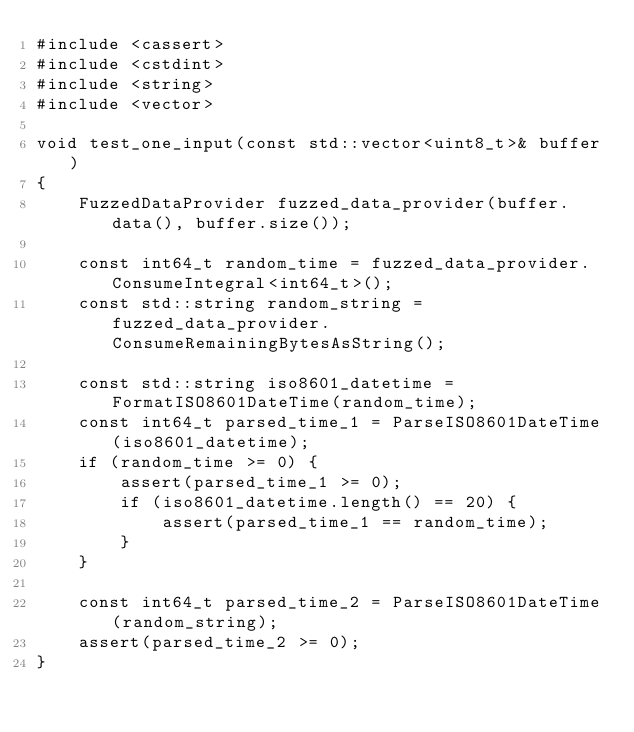Convert code to text. <code><loc_0><loc_0><loc_500><loc_500><_C++_>#include <cassert>
#include <cstdint>
#include <string>
#include <vector>

void test_one_input(const std::vector<uint8_t>& buffer)
{
    FuzzedDataProvider fuzzed_data_provider(buffer.data(), buffer.size());

    const int64_t random_time = fuzzed_data_provider.ConsumeIntegral<int64_t>();
    const std::string random_string = fuzzed_data_provider.ConsumeRemainingBytesAsString();

    const std::string iso8601_datetime = FormatISO8601DateTime(random_time);
    const int64_t parsed_time_1 = ParseISO8601DateTime(iso8601_datetime);
    if (random_time >= 0) {
        assert(parsed_time_1 >= 0);
        if (iso8601_datetime.length() == 20) {
            assert(parsed_time_1 == random_time);
        }
    }

    const int64_t parsed_time_2 = ParseISO8601DateTime(random_string);
    assert(parsed_time_2 >= 0);
}
</code> 